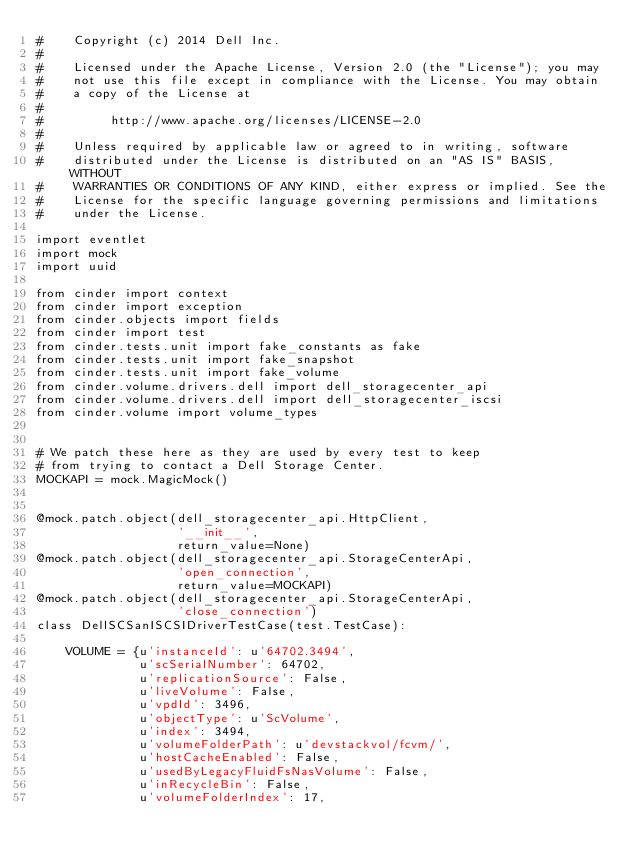Convert code to text. <code><loc_0><loc_0><loc_500><loc_500><_Python_>#    Copyright (c) 2014 Dell Inc.
#
#    Licensed under the Apache License, Version 2.0 (the "License"); you may
#    not use this file except in compliance with the License. You may obtain
#    a copy of the License at
#
#         http://www.apache.org/licenses/LICENSE-2.0
#
#    Unless required by applicable law or agreed to in writing, software
#    distributed under the License is distributed on an "AS IS" BASIS, WITHOUT
#    WARRANTIES OR CONDITIONS OF ANY KIND, either express or implied. See the
#    License for the specific language governing permissions and limitations
#    under the License.

import eventlet
import mock
import uuid

from cinder import context
from cinder import exception
from cinder.objects import fields
from cinder import test
from cinder.tests.unit import fake_constants as fake
from cinder.tests.unit import fake_snapshot
from cinder.tests.unit import fake_volume
from cinder.volume.drivers.dell import dell_storagecenter_api
from cinder.volume.drivers.dell import dell_storagecenter_iscsi
from cinder.volume import volume_types


# We patch these here as they are used by every test to keep
# from trying to contact a Dell Storage Center.
MOCKAPI = mock.MagicMock()


@mock.patch.object(dell_storagecenter_api.HttpClient,
                   '__init__',
                   return_value=None)
@mock.patch.object(dell_storagecenter_api.StorageCenterApi,
                   'open_connection',
                   return_value=MOCKAPI)
@mock.patch.object(dell_storagecenter_api.StorageCenterApi,
                   'close_connection')
class DellSCSanISCSIDriverTestCase(test.TestCase):

    VOLUME = {u'instanceId': u'64702.3494',
              u'scSerialNumber': 64702,
              u'replicationSource': False,
              u'liveVolume': False,
              u'vpdId': 3496,
              u'objectType': u'ScVolume',
              u'index': 3494,
              u'volumeFolderPath': u'devstackvol/fcvm/',
              u'hostCacheEnabled': False,
              u'usedByLegacyFluidFsNasVolume': False,
              u'inRecycleBin': False,
              u'volumeFolderIndex': 17,</code> 